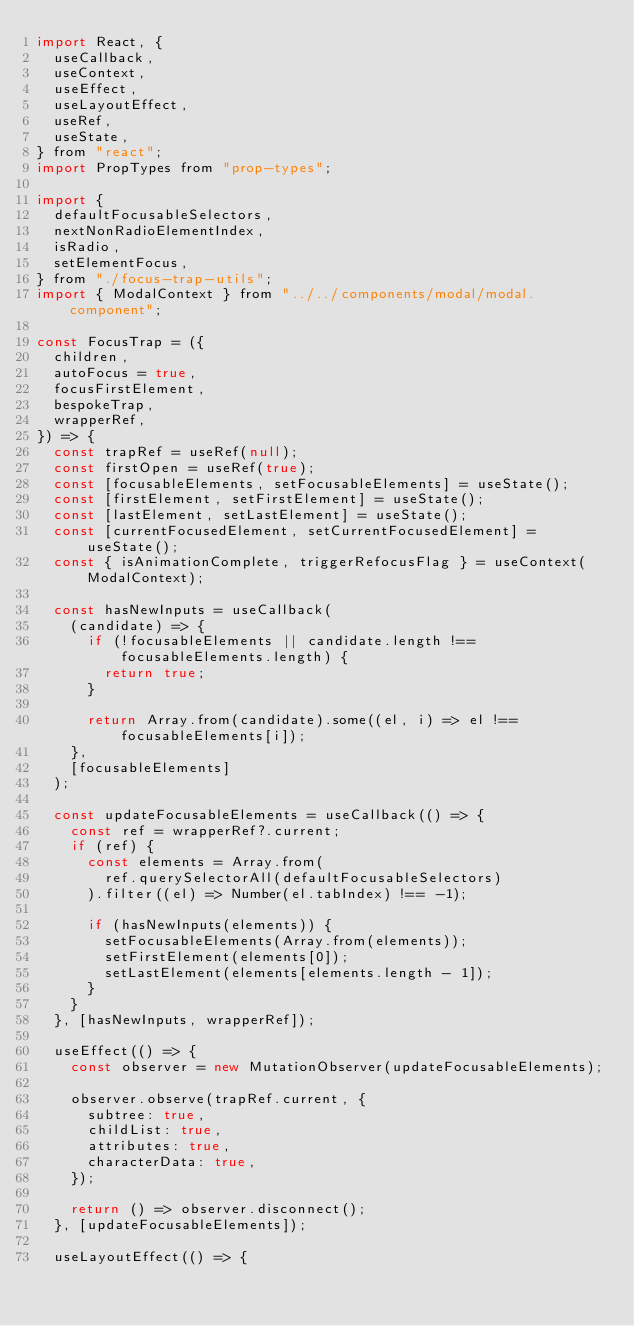<code> <loc_0><loc_0><loc_500><loc_500><_JavaScript_>import React, {
  useCallback,
  useContext,
  useEffect,
  useLayoutEffect,
  useRef,
  useState,
} from "react";
import PropTypes from "prop-types";

import {
  defaultFocusableSelectors,
  nextNonRadioElementIndex,
  isRadio,
  setElementFocus,
} from "./focus-trap-utils";
import { ModalContext } from "../../components/modal/modal.component";

const FocusTrap = ({
  children,
  autoFocus = true,
  focusFirstElement,
  bespokeTrap,
  wrapperRef,
}) => {
  const trapRef = useRef(null);
  const firstOpen = useRef(true);
  const [focusableElements, setFocusableElements] = useState();
  const [firstElement, setFirstElement] = useState();
  const [lastElement, setLastElement] = useState();
  const [currentFocusedElement, setCurrentFocusedElement] = useState();
  const { isAnimationComplete, triggerRefocusFlag } = useContext(ModalContext);

  const hasNewInputs = useCallback(
    (candidate) => {
      if (!focusableElements || candidate.length !== focusableElements.length) {
        return true;
      }

      return Array.from(candidate).some((el, i) => el !== focusableElements[i]);
    },
    [focusableElements]
  );

  const updateFocusableElements = useCallback(() => {
    const ref = wrapperRef?.current;
    if (ref) {
      const elements = Array.from(
        ref.querySelectorAll(defaultFocusableSelectors)
      ).filter((el) => Number(el.tabIndex) !== -1);

      if (hasNewInputs(elements)) {
        setFocusableElements(Array.from(elements));
        setFirstElement(elements[0]);
        setLastElement(elements[elements.length - 1]);
      }
    }
  }, [hasNewInputs, wrapperRef]);

  useEffect(() => {
    const observer = new MutationObserver(updateFocusableElements);

    observer.observe(trapRef.current, {
      subtree: true,
      childList: true,
      attributes: true,
      characterData: true,
    });

    return () => observer.disconnect();
  }, [updateFocusableElements]);

  useLayoutEffect(() => {</code> 